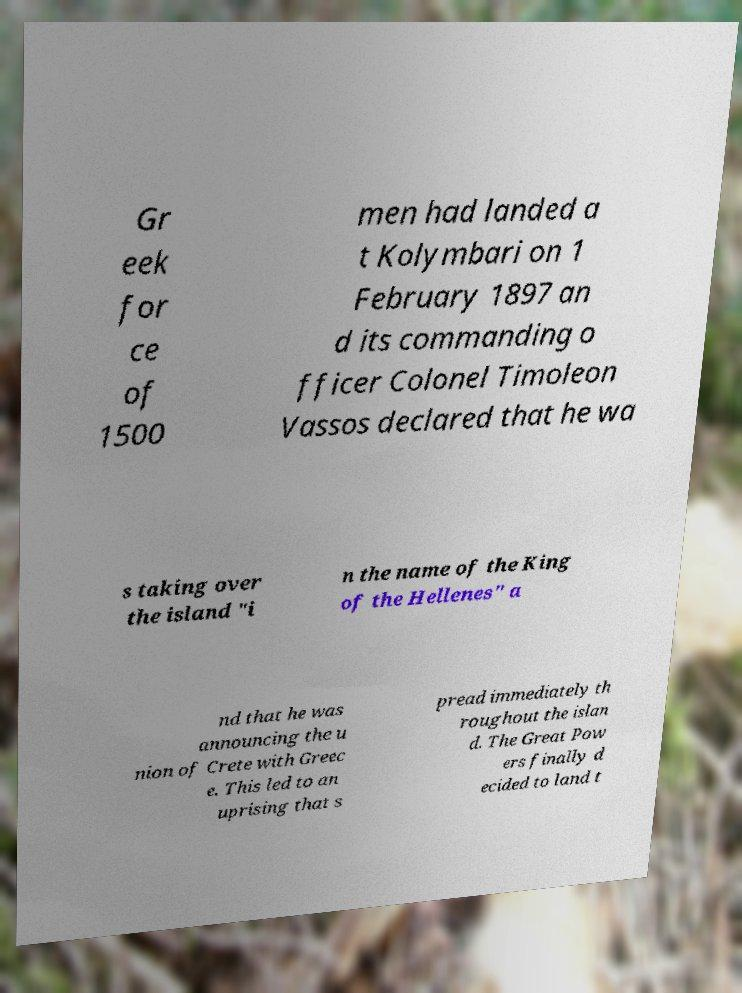Can you accurately transcribe the text from the provided image for me? Gr eek for ce of 1500 men had landed a t Kolymbari on 1 February 1897 an d its commanding o fficer Colonel Timoleon Vassos declared that he wa s taking over the island "i n the name of the King of the Hellenes" a nd that he was announcing the u nion of Crete with Greec e. This led to an uprising that s pread immediately th roughout the islan d. The Great Pow ers finally d ecided to land t 